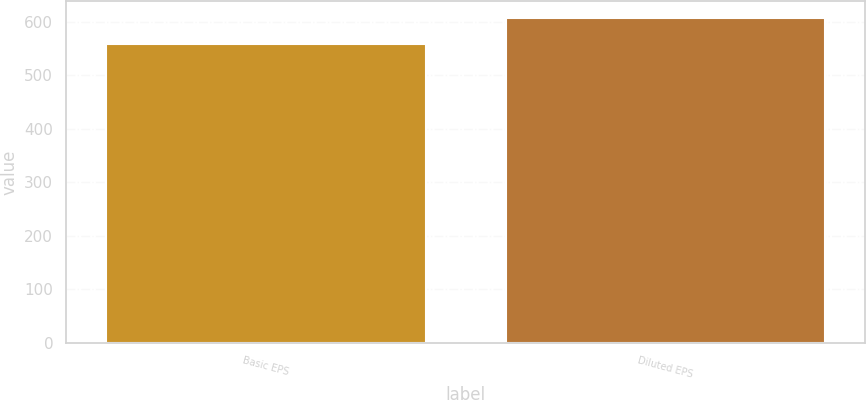Convert chart. <chart><loc_0><loc_0><loc_500><loc_500><bar_chart><fcel>Basic EPS<fcel>Diluted EPS<nl><fcel>557.8<fcel>607.7<nl></chart> 